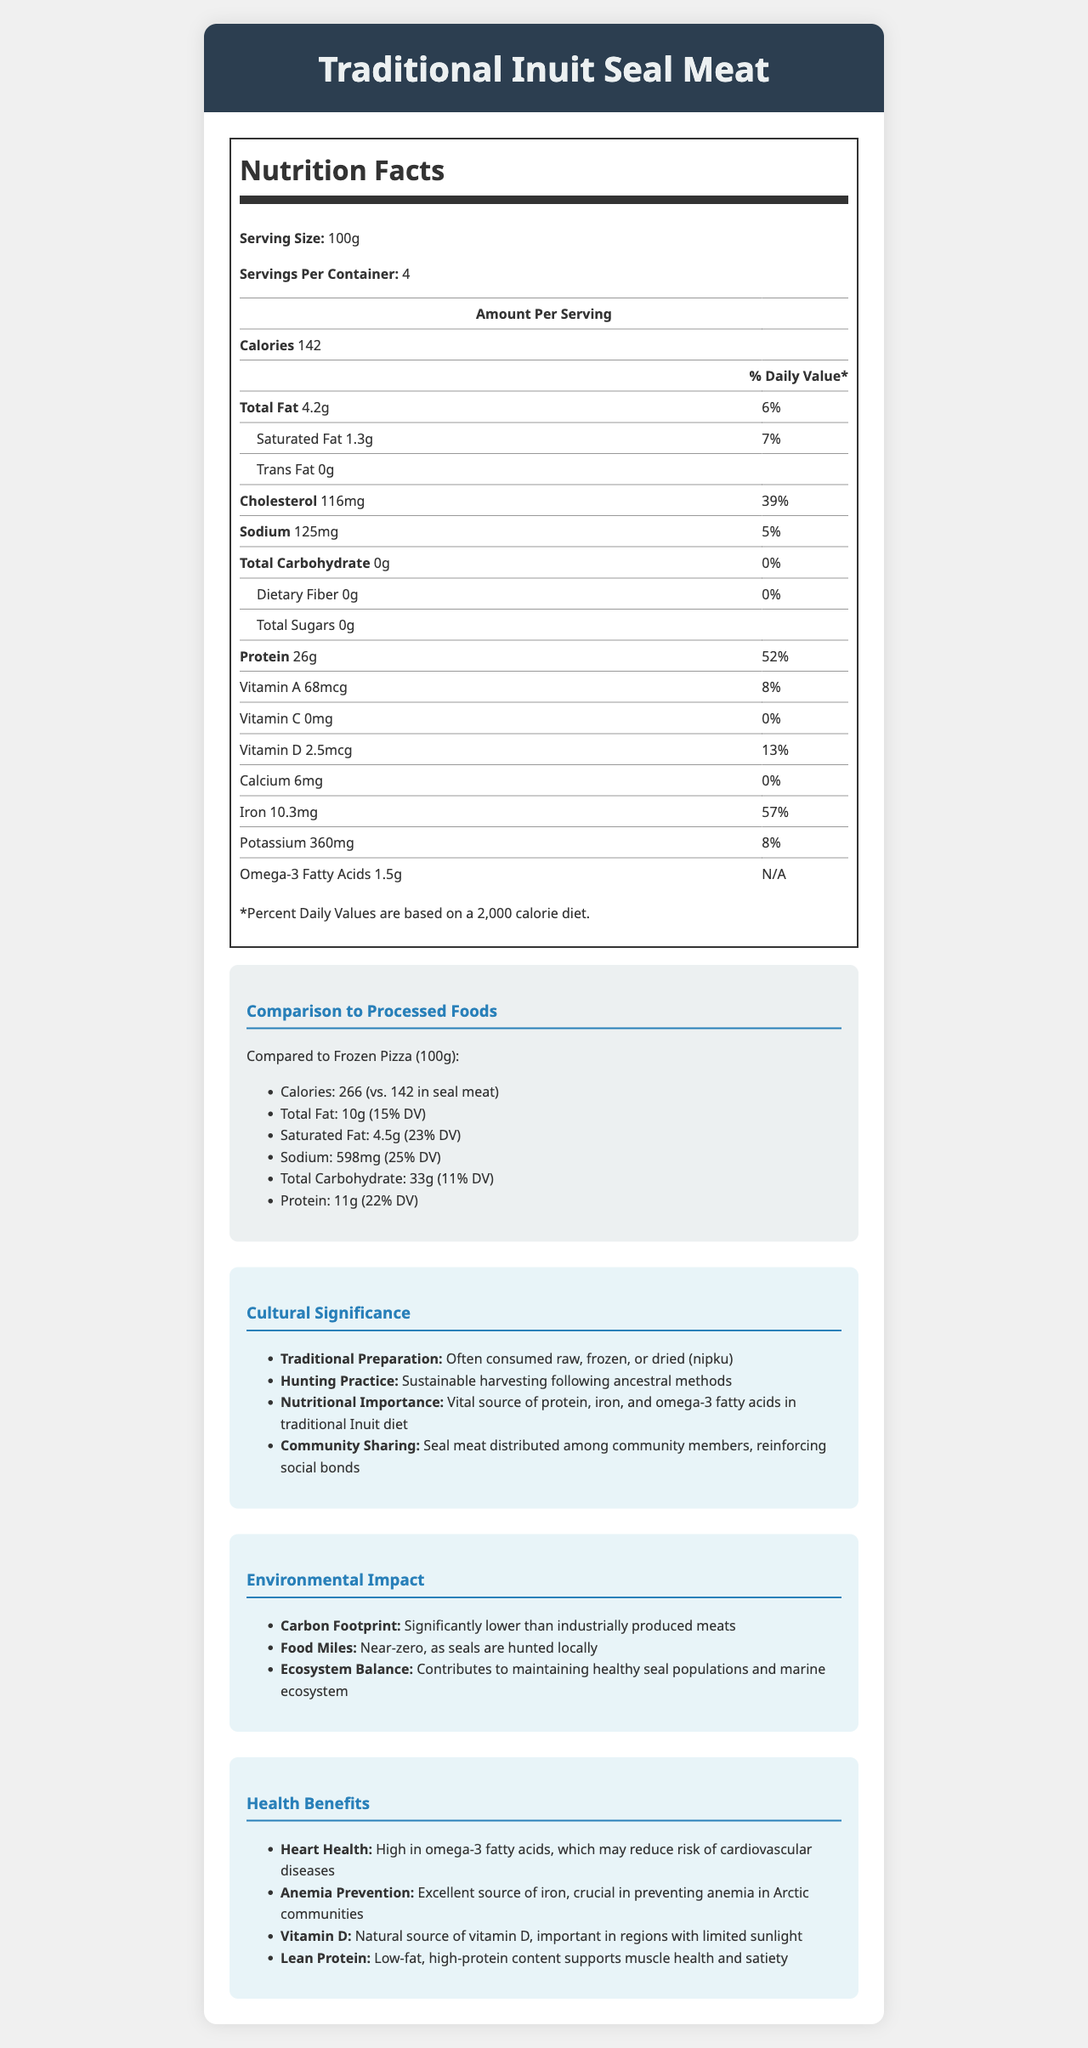what is the serving size of Traditional Inuit Seal Meat? The serving size is stated directly in the document under the "Serving Size" section.
Answer: 100g how many grams of protein are in a serving of Traditional Inuit Seal Meat? The amount of protein is listed as 26g under the protein section of the nutrition facts.
Answer: 26g Compare the calories between Traditional Inuit Seal Meat and Frozen Pizza per 100g. The document lists the calories for each: 142 for seal meat and 266 for Frozen Pizza.
Answer: Seal meat has 142 calories, while Frozen Pizza has 266 calories what percentage of the daily value for iron does Traditional Inuit Seal Meat provide? The daily value percentage for iron is directly listed as 57% in the document.
Answer: 57% What is the primary source of Vitamin D in Traditional Inuit Seal Meat? The document mentions that seal meat is a natural source of Vitamin D under the health benefits section.
Answer: Natural source Which has a higher sodium content, Traditional Inuit Seal Meat or Frozen Pizza? A. Seal Meat B. Frozen Pizza C. Both are the same D. Cannot be determined The document lists sodium content: Seal meat has 125mg, and Frozen Pizza has 598mg.
Answer: B Which of the following is NOT listed as a health benefit of Traditional Inuit Seal Meat? 1. Heart Health 2. Bone Strength 3. Anemia Prevention 4. Lean Protein Bone strength is not listed among the health benefits, while heart health, anemia prevention, and lean protein are mentioned.
Answer: 2. Bone Strength Does Traditional Inuit Seal Meat contain any dietary fiber? The document lists dietary fiber as 0g in the nutrition facts.
Answer: No Is seal meat traditionally consumed cooked according to the document? The document states that traditional preparation methods include consuming it raw, frozen, or dried (nipku).
Answer: No Summarize the environmental impact of Traditional Inuit Seal Meat as described in the document. The document details the carbon footprint, food miles, and ecosystem balance in the environmental impact section.
Answer: Traditional Inuit Seal Meat has a significantly lower carbon footprint than industrially produced meats, near-zero food miles since seals are hunted locally, and it contributes to maintaining a healthy ecosystem balance. What is the exact method used to capture the nutritional information for Traditional Inuit Seal Meat in this document? The document does not provide details on the methods used to capture nutritional information.
Answer: Not enough information 